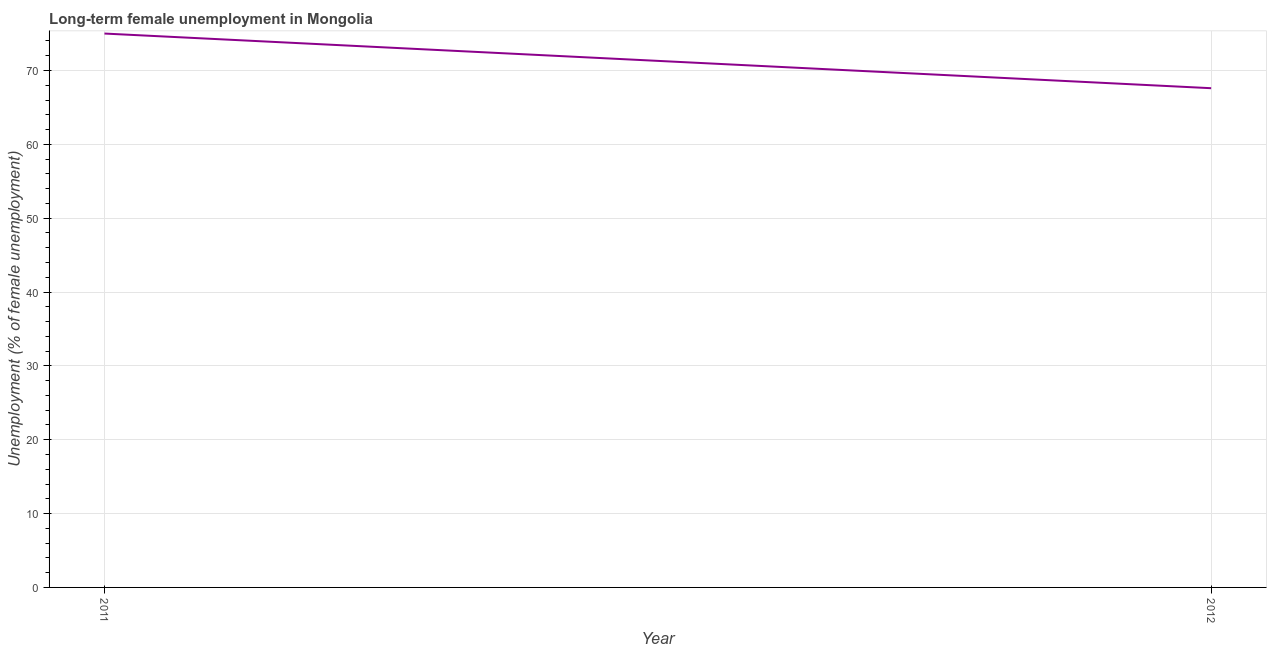What is the long-term female unemployment in 2012?
Your answer should be compact. 67.6. Across all years, what is the minimum long-term female unemployment?
Your answer should be very brief. 67.6. In which year was the long-term female unemployment minimum?
Ensure brevity in your answer.  2012. What is the sum of the long-term female unemployment?
Your answer should be compact. 142.6. What is the difference between the long-term female unemployment in 2011 and 2012?
Your answer should be compact. 7.4. What is the average long-term female unemployment per year?
Ensure brevity in your answer.  71.3. What is the median long-term female unemployment?
Your answer should be compact. 71.3. In how many years, is the long-term female unemployment greater than 64 %?
Your response must be concise. 2. What is the ratio of the long-term female unemployment in 2011 to that in 2012?
Provide a succinct answer. 1.11. Does the long-term female unemployment monotonically increase over the years?
Keep it short and to the point. No. Does the graph contain any zero values?
Give a very brief answer. No. What is the title of the graph?
Ensure brevity in your answer.  Long-term female unemployment in Mongolia. What is the label or title of the X-axis?
Provide a short and direct response. Year. What is the label or title of the Y-axis?
Make the answer very short. Unemployment (% of female unemployment). What is the Unemployment (% of female unemployment) in 2012?
Your answer should be very brief. 67.6. What is the difference between the Unemployment (% of female unemployment) in 2011 and 2012?
Keep it short and to the point. 7.4. What is the ratio of the Unemployment (% of female unemployment) in 2011 to that in 2012?
Your answer should be compact. 1.11. 